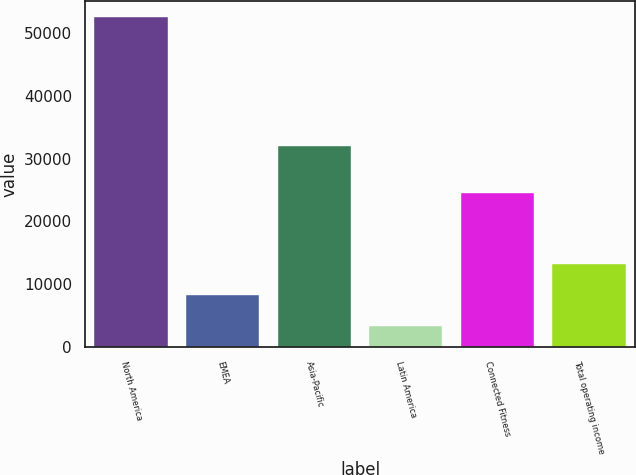<chart> <loc_0><loc_0><loc_500><loc_500><bar_chart><fcel>North America<fcel>EMEA<fcel>Asia-Pacific<fcel>Latin America<fcel>Connected Fitness<fcel>Total operating income<nl><fcel>52537<fcel>8298<fcel>31980<fcel>3298<fcel>24481<fcel>13221.9<nl></chart> 